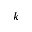Convert formula to latex. <formula><loc_0><loc_0><loc_500><loc_500>k</formula> 